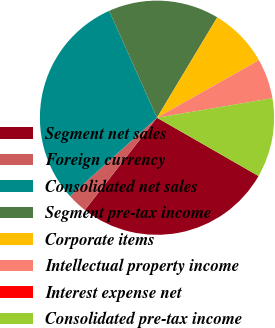Convert chart. <chart><loc_0><loc_0><loc_500><loc_500><pie_chart><fcel>Segment net sales<fcel>Foreign currency<fcel>Consolidated net sales<fcel>Segment pre-tax income<fcel>Corporate items<fcel>Intellectual property income<fcel>Interest expense net<fcel>Consolidated pre-tax income<nl><fcel>27.26%<fcel>2.76%<fcel>29.99%<fcel>15.3%<fcel>8.22%<fcel>5.49%<fcel>0.02%<fcel>10.96%<nl></chart> 